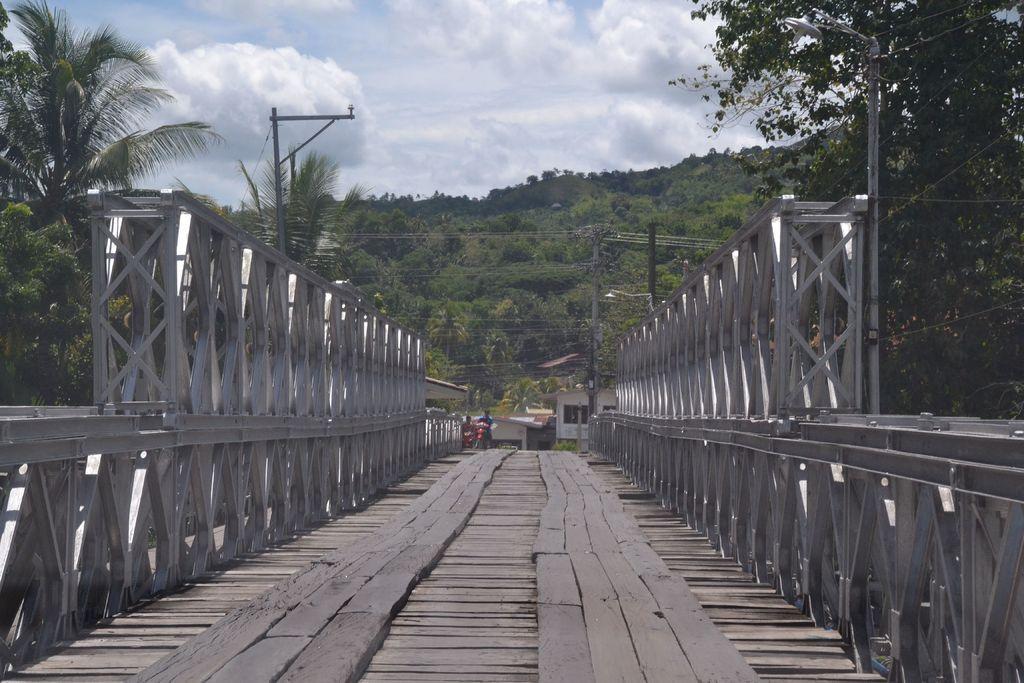In one or two sentences, can you explain what this image depicts? In the foreground I can see a bridge, two persons are riding bikes and light poles. In the background I can see trees, wires, mountains, houses and the sky. This image is taken may be during a day. 